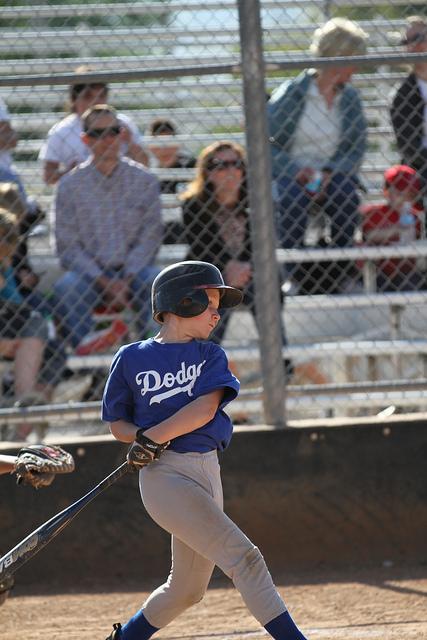What sport is depicted?
Give a very brief answer. Baseball. What is the player holding in his arms?
Quick response, please. Bat. How many fans are behind the player?
Give a very brief answer. 9. How many batting helmets are in the picture?
Quick response, please. 1. 